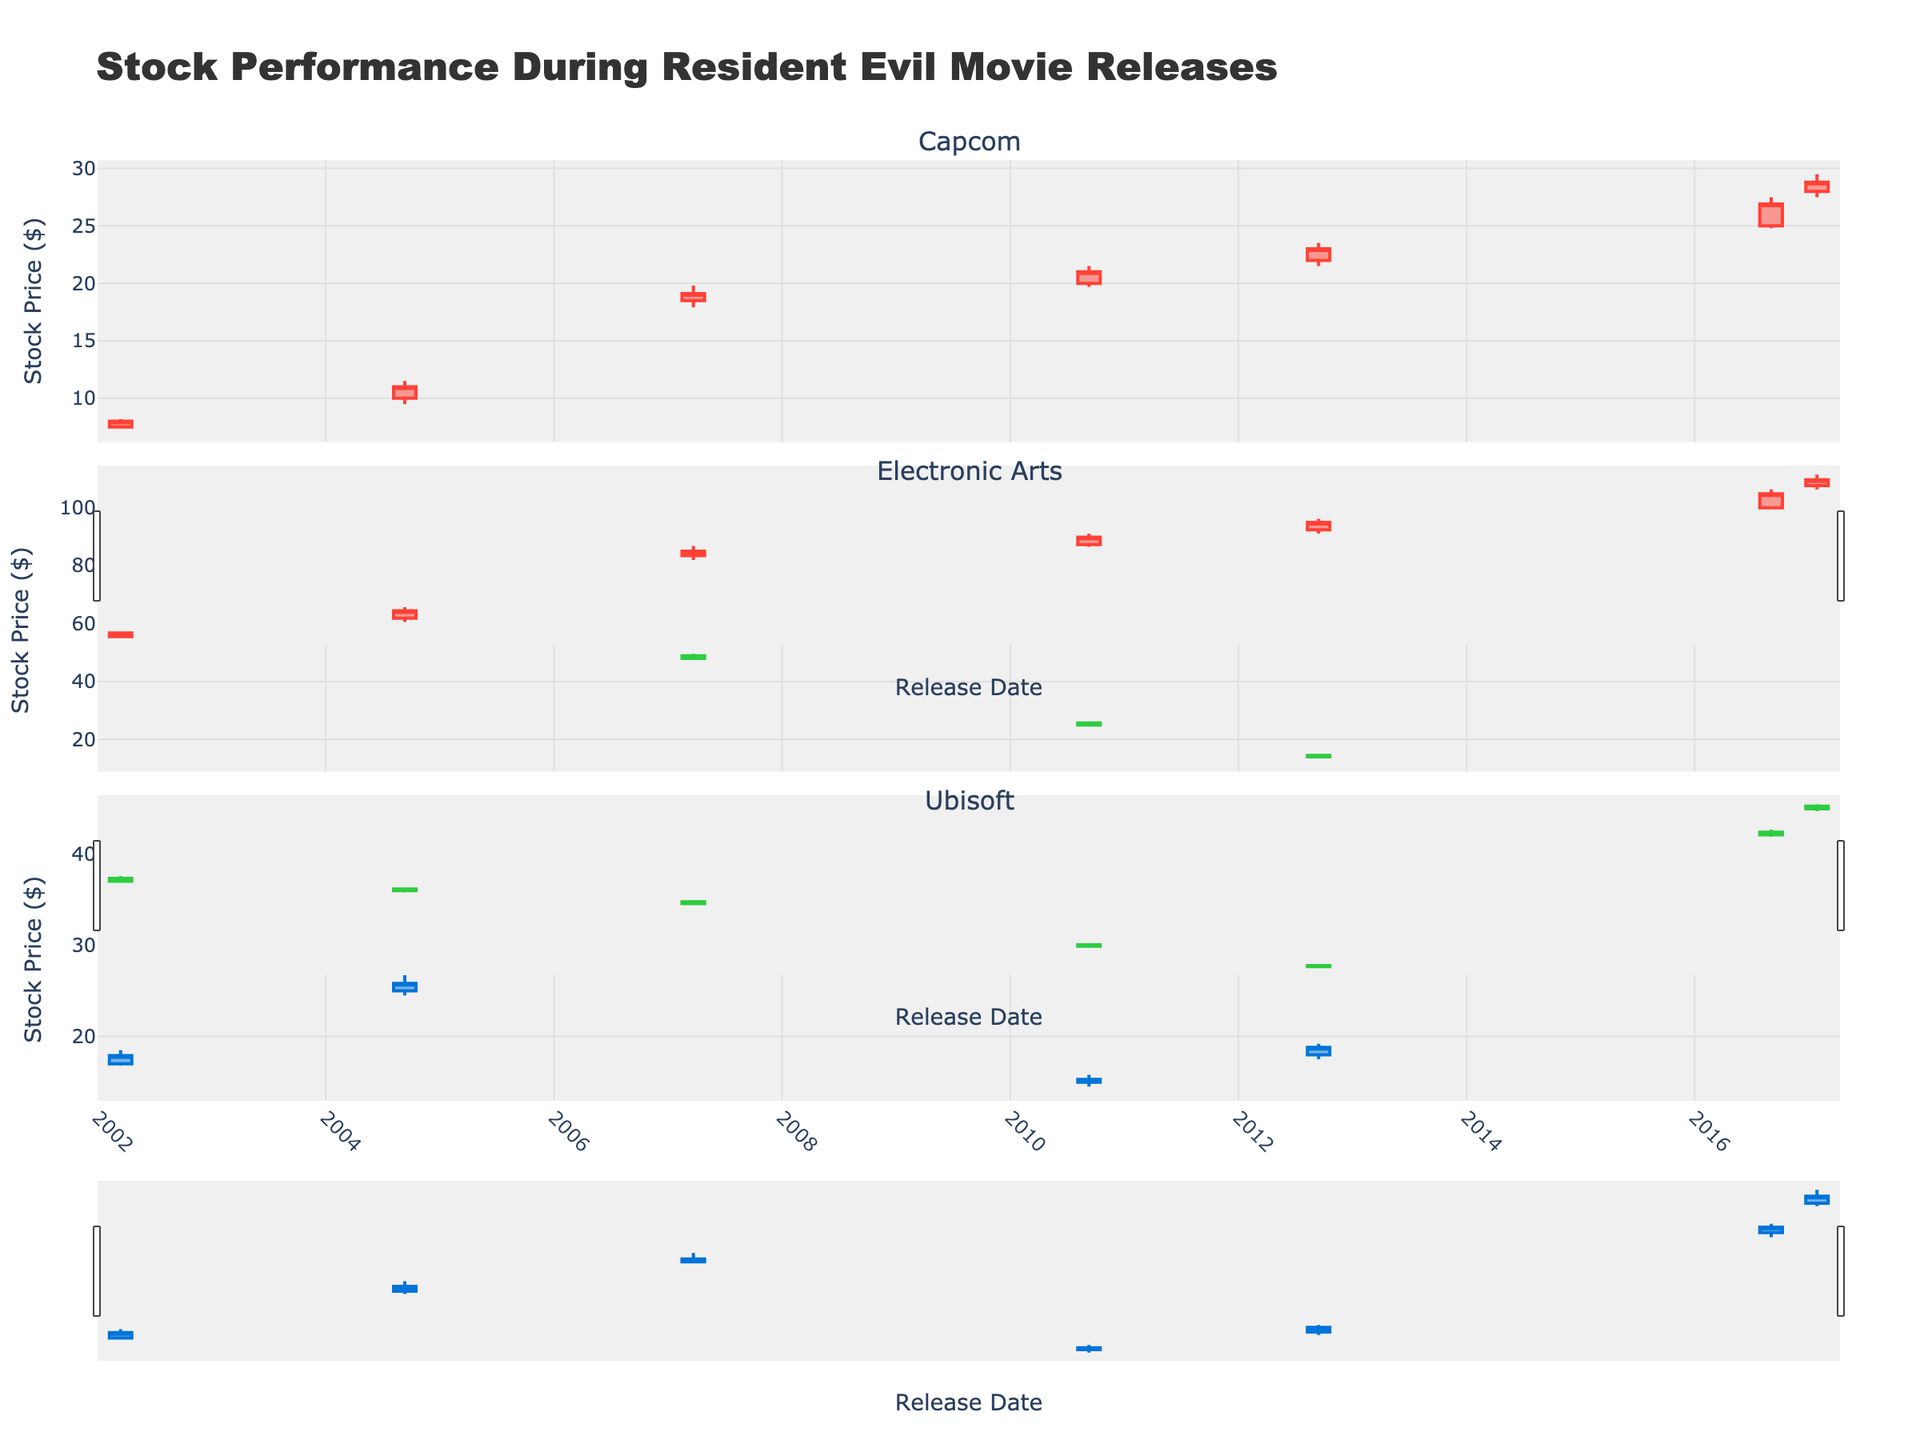9. Did Electronic Arts stock ever decrease between any two consecutive movie release dates? Compare EA's closing prices across consecutive dates to check if the closing price went down at any point. From 2002 to 2017, find decreases if any.
Answer: Yes 10. For which company and on which date was the opening stock price the lowest, and what was that price? Review the opening stock prices of all companies and dates to identify the lowest price and its corresponding company and date.
Answer: Ubisoft, 2010-09-10, 15.00 